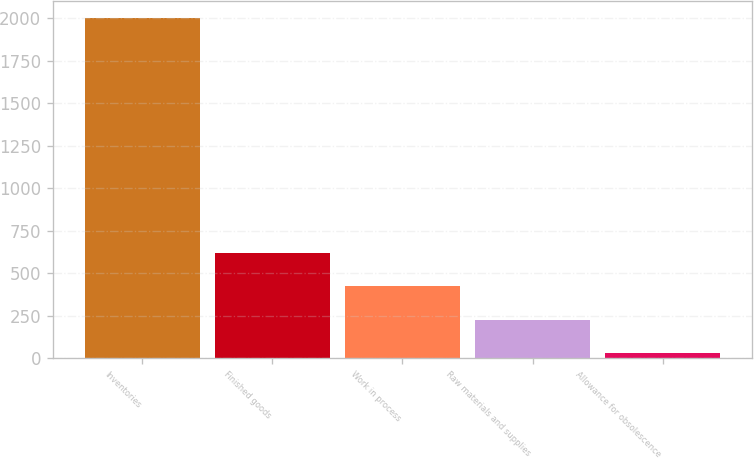Convert chart to OTSL. <chart><loc_0><loc_0><loc_500><loc_500><bar_chart><fcel>Inventories<fcel>Finished goods<fcel>Work in process<fcel>Raw materials and supplies<fcel>Allowance for obsolescence<nl><fcel>2002<fcel>619.57<fcel>422.08<fcel>224.59<fcel>27.1<nl></chart> 